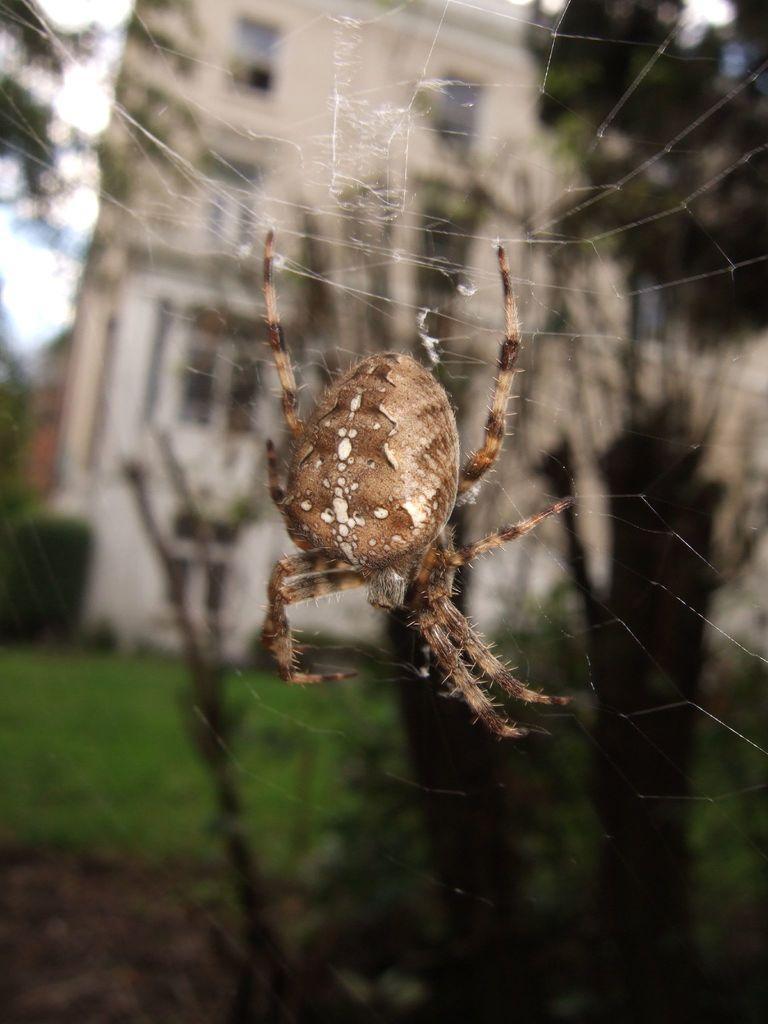Please provide a concise description of this image. Here in this picture we can see a spider represent on the spider web over there and behind that we can see plants and trees and a building present over there. 